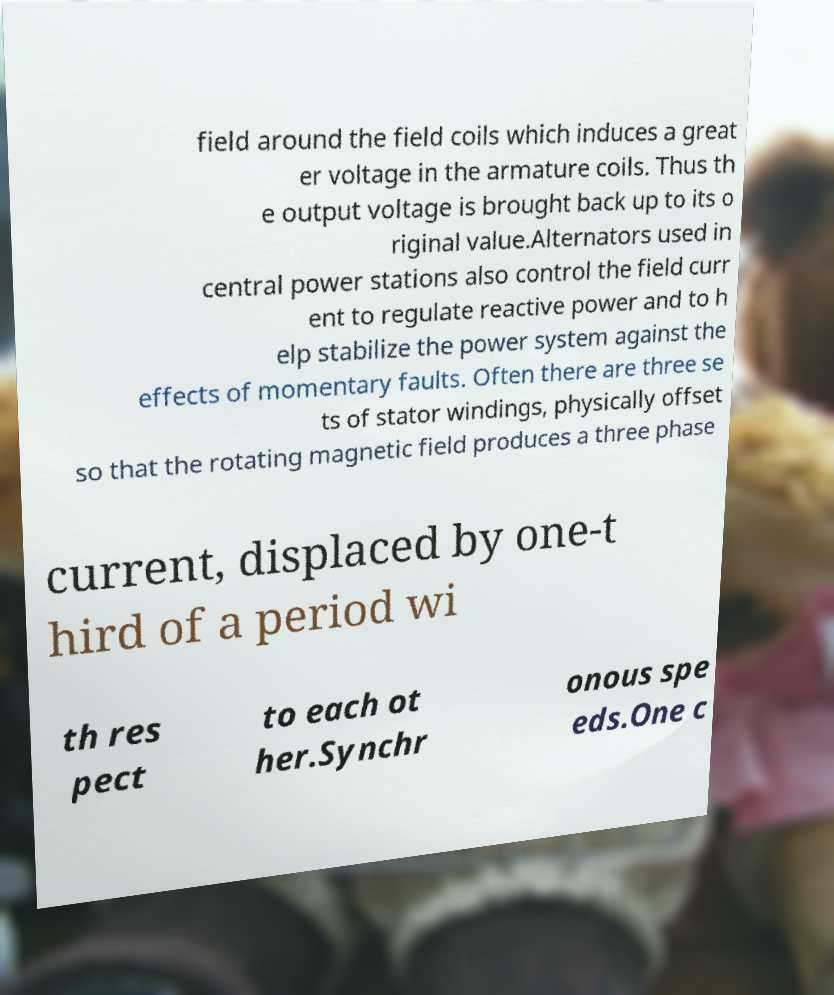Could you extract and type out the text from this image? field around the field coils which induces a great er voltage in the armature coils. Thus th e output voltage is brought back up to its o riginal value.Alternators used in central power stations also control the field curr ent to regulate reactive power and to h elp stabilize the power system against the effects of momentary faults. Often there are three se ts of stator windings, physically offset so that the rotating magnetic field produces a three phase current, displaced by one-t hird of a period wi th res pect to each ot her.Synchr onous spe eds.One c 